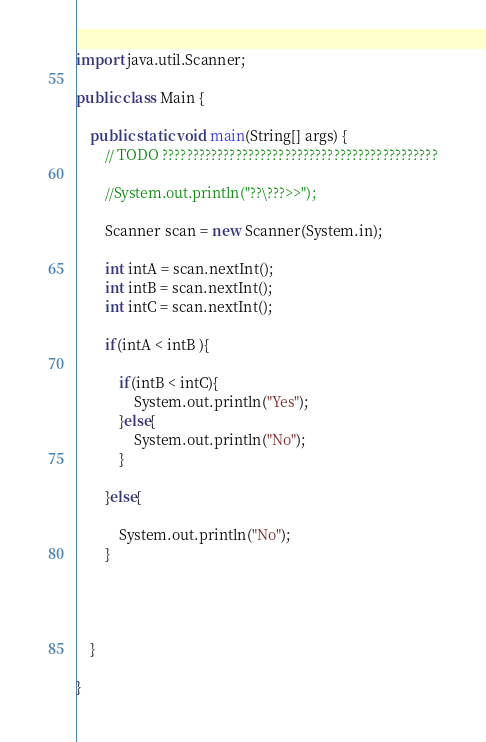<code> <loc_0><loc_0><loc_500><loc_500><_Java_>import java.util.Scanner;

public class Main {

	public static void main(String[] args) {
		// TODO ?????????????????????????????????????????????

		//System.out.println("??\???>>");

		Scanner scan = new Scanner(System.in);

		int intA = scan.nextInt();
		int intB = scan.nextInt();
		int intC = scan.nextInt();

		if(intA < intB ){
			
			if(intB < intC){
				System.out.println("Yes");
			}else{				
				System.out.println("No");
			}
		
		}else{
			
			System.out.println("No");
		} 
			
		
			

	}

}</code> 